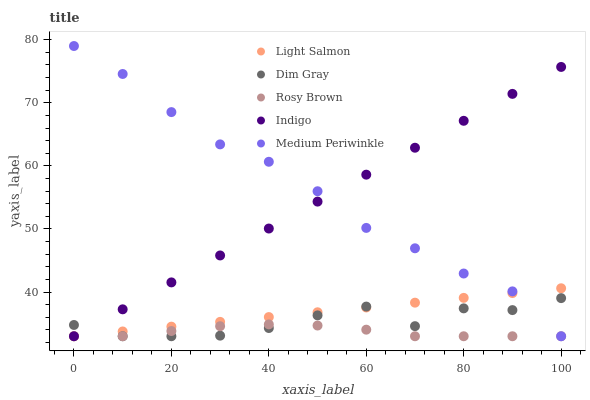Does Rosy Brown have the minimum area under the curve?
Answer yes or no. Yes. Does Medium Periwinkle have the maximum area under the curve?
Answer yes or no. Yes. Does Light Salmon have the minimum area under the curve?
Answer yes or no. No. Does Light Salmon have the maximum area under the curve?
Answer yes or no. No. Is Light Salmon the smoothest?
Answer yes or no. Yes. Is Dim Gray the roughest?
Answer yes or no. Yes. Is Dim Gray the smoothest?
Answer yes or no. No. Is Light Salmon the roughest?
Answer yes or no. No. Does Medium Periwinkle have the lowest value?
Answer yes or no. Yes. Does Medium Periwinkle have the highest value?
Answer yes or no. Yes. Does Light Salmon have the highest value?
Answer yes or no. No. Does Indigo intersect Light Salmon?
Answer yes or no. Yes. Is Indigo less than Light Salmon?
Answer yes or no. No. Is Indigo greater than Light Salmon?
Answer yes or no. No. 